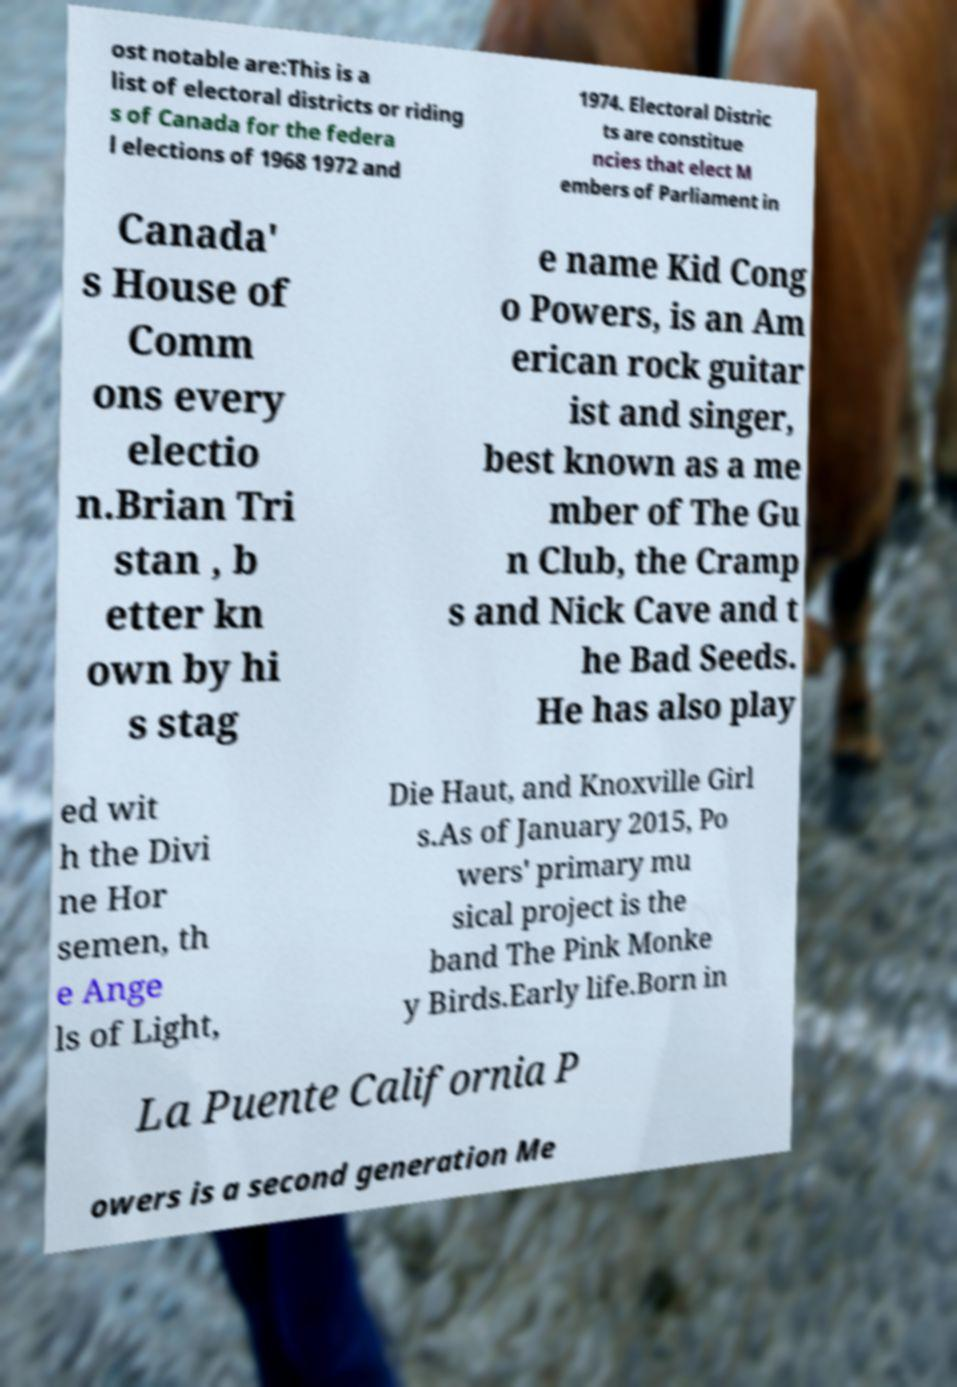I need the written content from this picture converted into text. Can you do that? ost notable are:This is a list of electoral districts or riding s of Canada for the federa l elections of 1968 1972 and 1974. Electoral Distric ts are constitue ncies that elect M embers of Parliament in Canada' s House of Comm ons every electio n.Brian Tri stan , b etter kn own by hi s stag e name Kid Cong o Powers, is an Am erican rock guitar ist and singer, best known as a me mber of The Gu n Club, the Cramp s and Nick Cave and t he Bad Seeds. He has also play ed wit h the Divi ne Hor semen, th e Ange ls of Light, Die Haut, and Knoxville Girl s.As of January 2015, Po wers' primary mu sical project is the band The Pink Monke y Birds.Early life.Born in La Puente California P owers is a second generation Me 